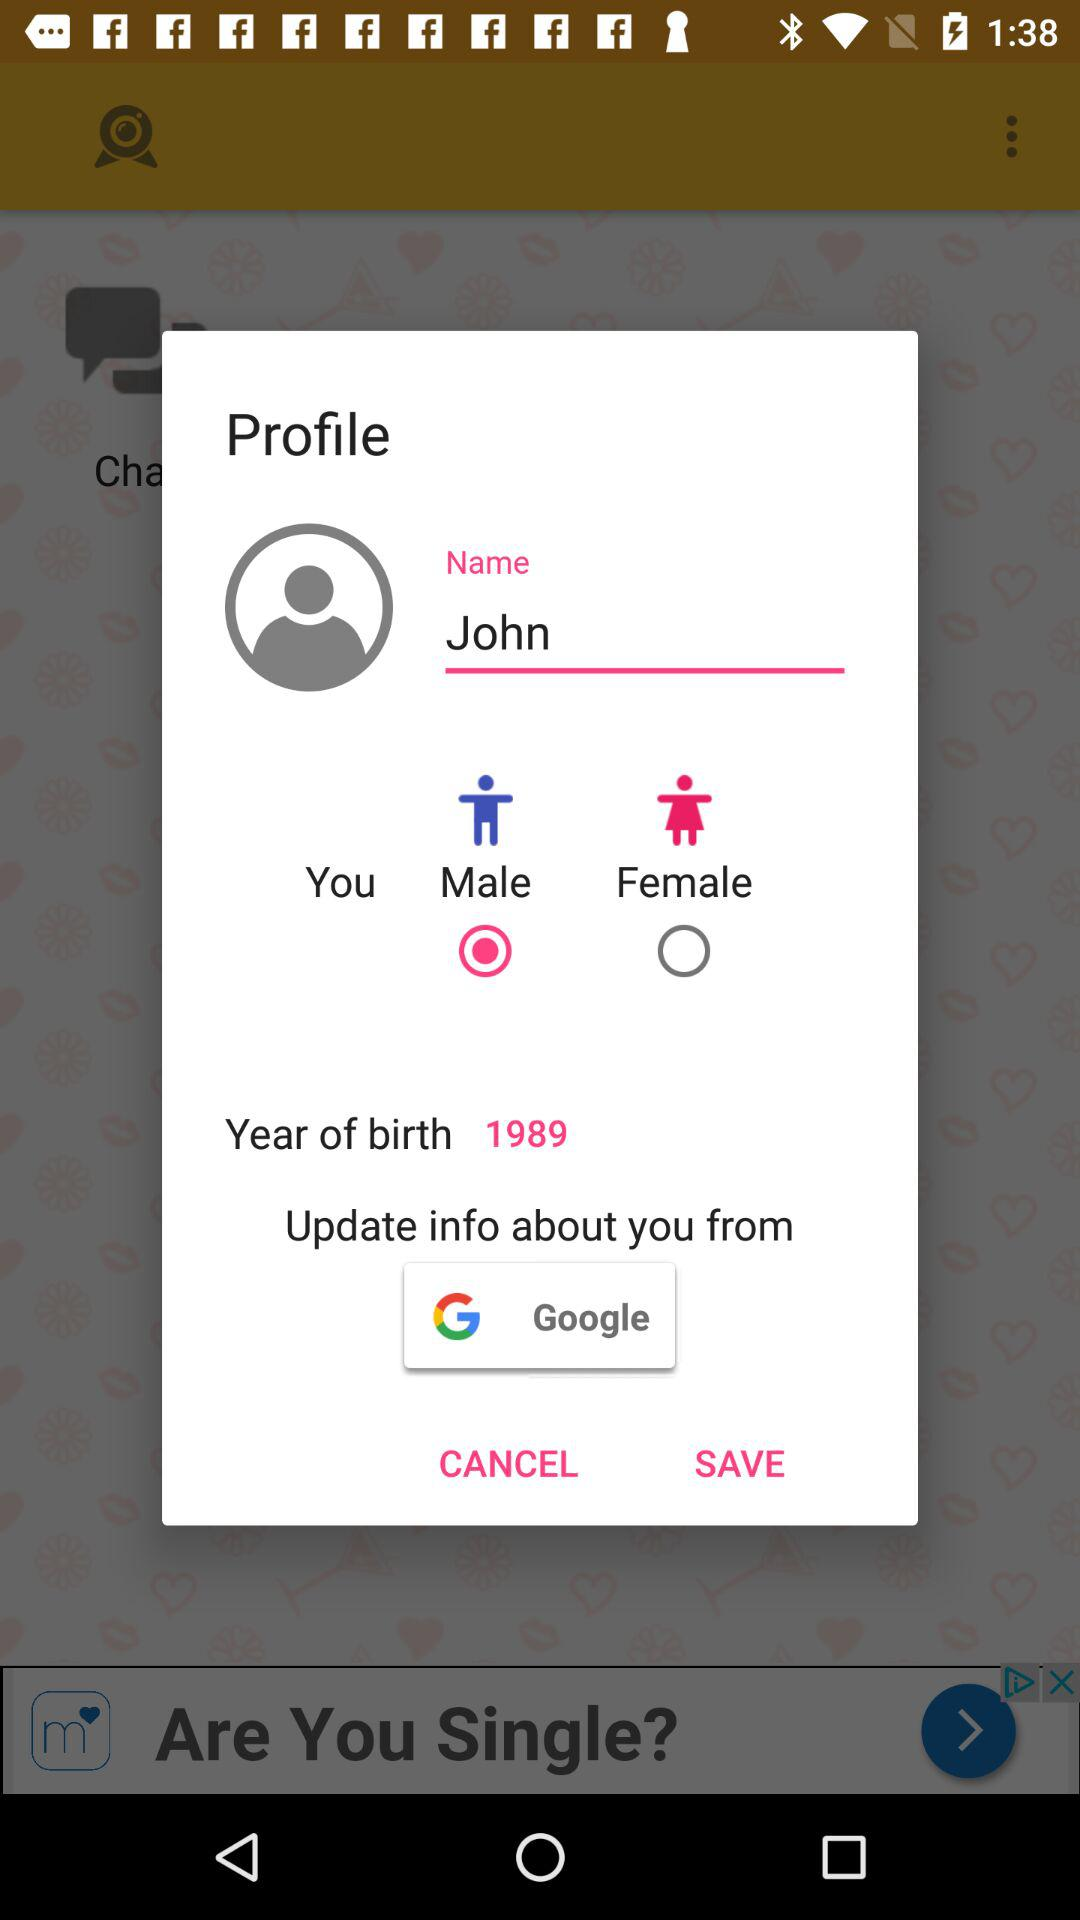What's the name of the person? The name of the person is John. 